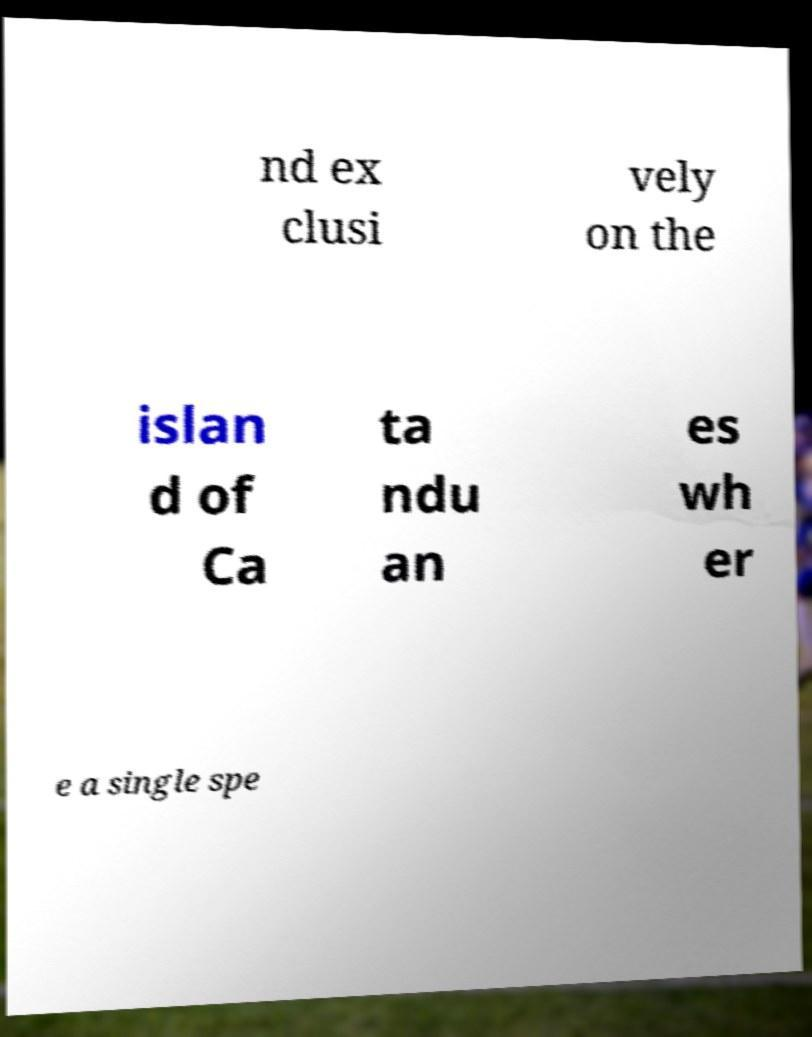Could you assist in decoding the text presented in this image and type it out clearly? nd ex clusi vely on the islan d of Ca ta ndu an es wh er e a single spe 